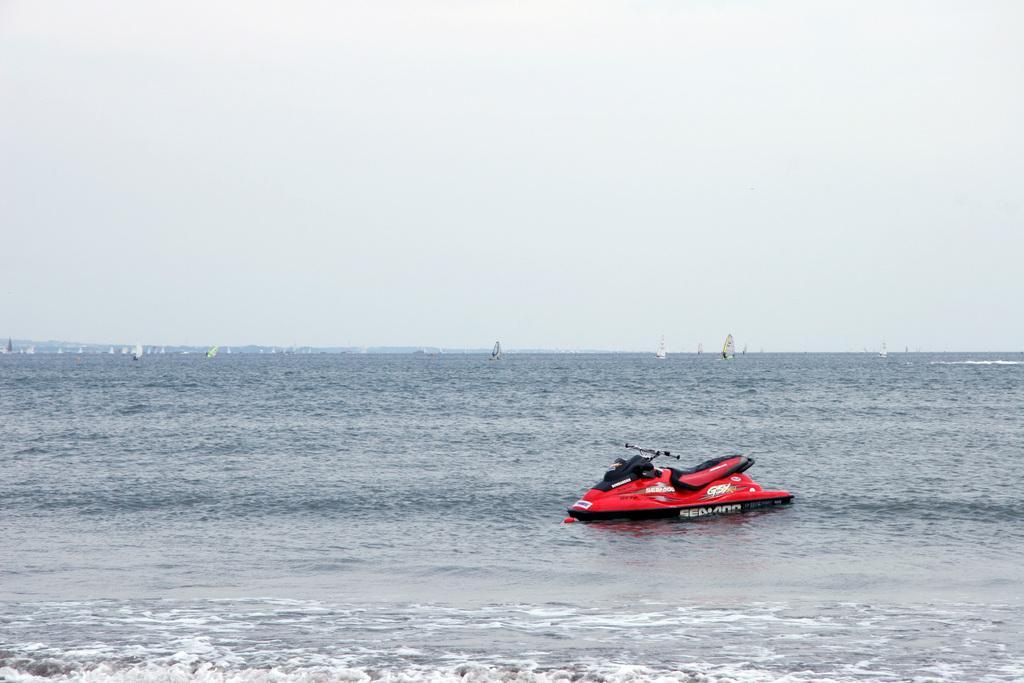How would you summarize this image in a sentence or two? On the right side, there is a red color boat on the water of the ocean, which is having tides. In the background, there are boats on the water and there are clouds in the blue sky. 